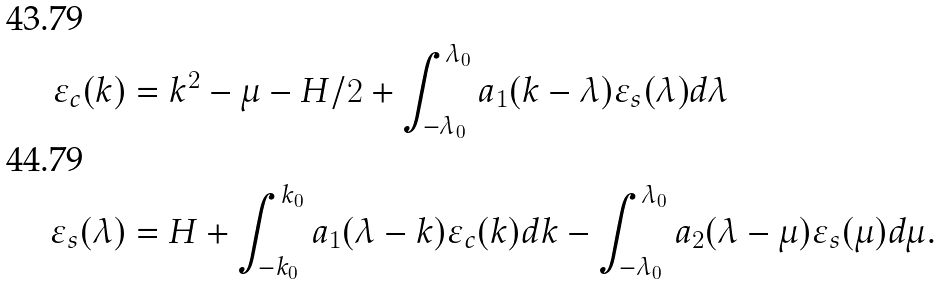Convert formula to latex. <formula><loc_0><loc_0><loc_500><loc_500>\varepsilon _ { c } ( k ) & = k ^ { 2 } - \mu - H / 2 + \int _ { - \lambda _ { 0 } } ^ { \lambda _ { 0 } } a _ { 1 } ( k - \lambda ) \varepsilon _ { s } ( \lambda ) d \lambda \\ \varepsilon _ { s } ( \lambda ) & = H + \int _ { - k _ { 0 } } ^ { k _ { 0 } } a _ { 1 } ( \lambda - k ) \varepsilon _ { c } ( k ) d k - \int _ { - \lambda _ { 0 } } ^ { \lambda _ { 0 } } a _ { 2 } ( \lambda - \mu ) \varepsilon _ { s } ( \mu ) d \mu .</formula> 